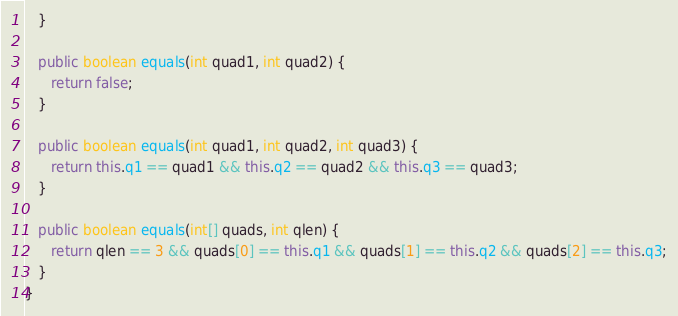<code> <loc_0><loc_0><loc_500><loc_500><_Java_>   }

   public boolean equals(int quad1, int quad2) {
      return false;
   }

   public boolean equals(int quad1, int quad2, int quad3) {
      return this.q1 == quad1 && this.q2 == quad2 && this.q3 == quad3;
   }

   public boolean equals(int[] quads, int qlen) {
      return qlen == 3 && quads[0] == this.q1 && quads[1] == this.q2 && quads[2] == this.q3;
   }
}
</code> 